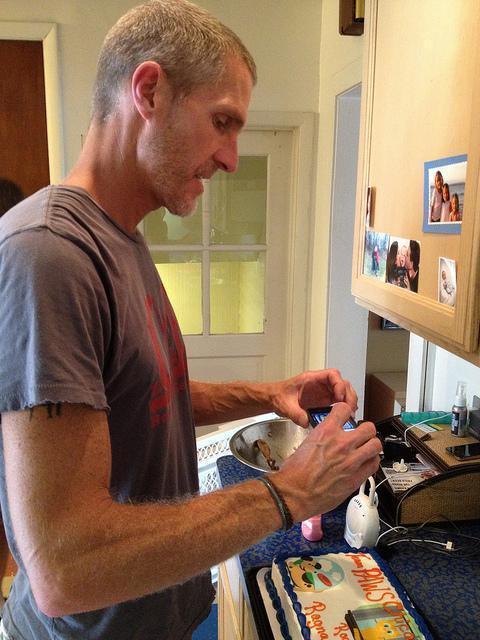What is the blue rectangular plastic item used to hold at the top of the desk?
From the following four choices, select the correct answer to address the question.
Options: Pills, stickers, screws, thumbtacks. Pills. 